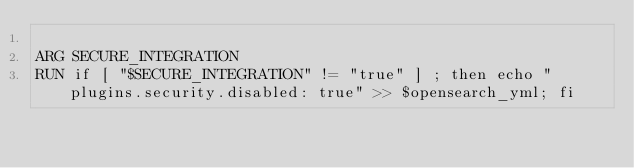Convert code to text. <code><loc_0><loc_0><loc_500><loc_500><_Dockerfile_>
ARG SECURE_INTEGRATION
RUN if [ "$SECURE_INTEGRATION" != "true" ] ; then echo "plugins.security.disabled: true" >> $opensearch_yml; fi
</code> 